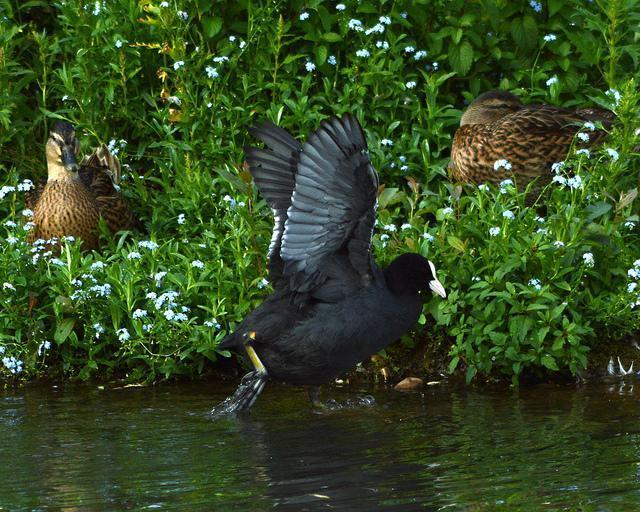How many brown ducks can you see?
Give a very brief answer. 2. How many birds can you see?
Give a very brief answer. 3. 